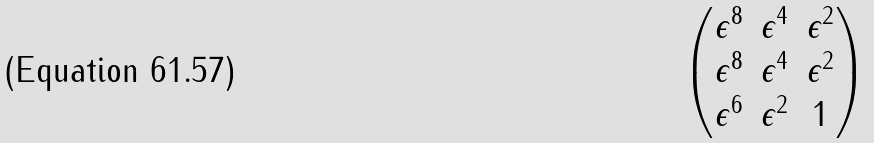Convert formula to latex. <formula><loc_0><loc_0><loc_500><loc_500>\begin{pmatrix} \epsilon ^ { 8 } & \epsilon ^ { 4 } & \epsilon ^ { 2 } \\ \epsilon ^ { 8 } & \epsilon ^ { 4 } & \epsilon ^ { 2 } \\ \epsilon ^ { 6 } & \epsilon ^ { 2 } & 1 \\ \end{pmatrix}</formula> 